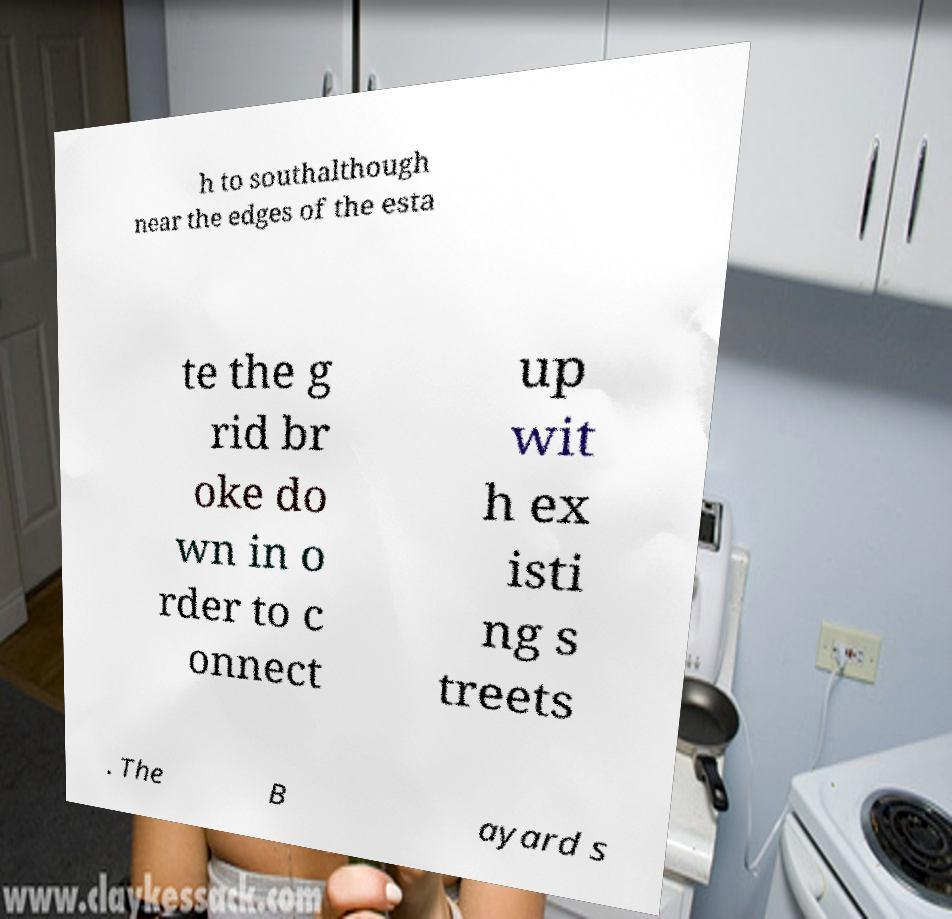Could you extract and type out the text from this image? h to southalthough near the edges of the esta te the g rid br oke do wn in o rder to c onnect up wit h ex isti ng s treets . The B ayard s 